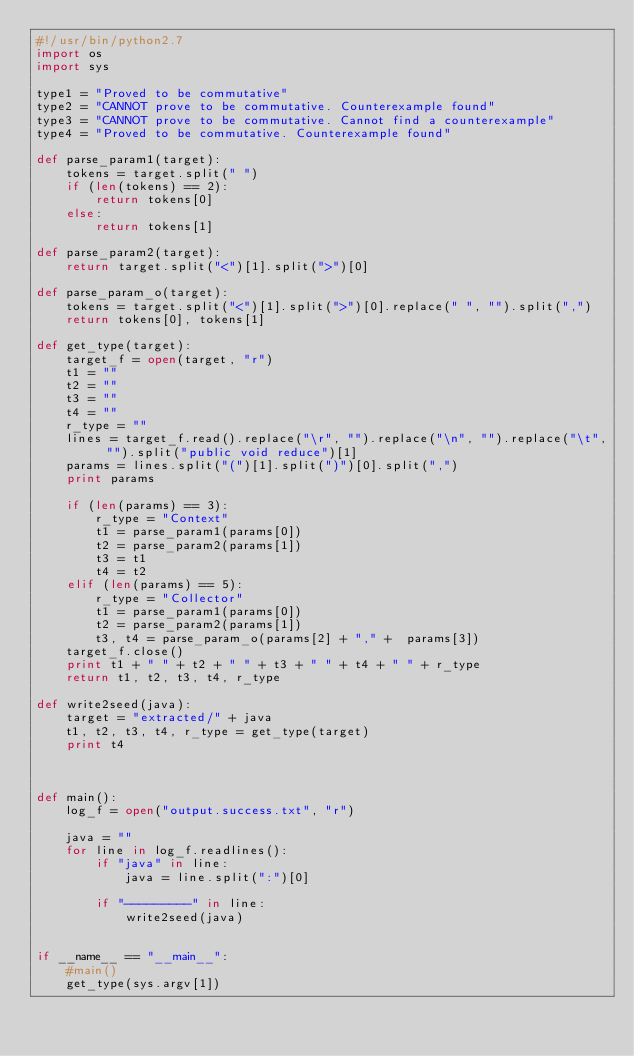Convert code to text. <code><loc_0><loc_0><loc_500><loc_500><_Python_>#!/usr/bin/python2.7
import os
import sys

type1 = "Proved to be commutative"
type2 = "CANNOT prove to be commutative. Counterexample found"
type3 = "CANNOT prove to be commutative. Cannot find a counterexample"
type4 = "Proved to be commutative. Counterexample found"

def parse_param1(target):
    tokens = target.split(" ")
    if (len(tokens) == 2):
        return tokens[0]
    else:
        return tokens[1]

def parse_param2(target):
    return target.split("<")[1].split(">")[0]

def parse_param_o(target):
    tokens = target.split("<")[1].split(">")[0].replace(" ", "").split(",")
    return tokens[0], tokens[1]

def get_type(target):
    target_f = open(target, "r")
    t1 = ""
    t2 = ""
    t3 = ""
    t4 = ""
    r_type = ""
    lines = target_f.read().replace("\r", "").replace("\n", "").replace("\t", "").split("public void reduce")[1]
    params = lines.split("(")[1].split(")")[0].split(",")
    print params

    if (len(params) == 3):
        r_type = "Context"
        t1 = parse_param1(params[0])
        t2 = parse_param2(params[1])
        t3 = t1
        t4 = t2
    elif (len(params) == 5):
        r_type = "Collector"
        t1 = parse_param1(params[0])
        t2 = parse_param2(params[1])
        t3, t4 = parse_param_o(params[2] + "," +  params[3])
    target_f.close()
    print t1 + " " + t2 + " " + t3 + " " + t4 + " " + r_type
    return t1, t2, t3, t4, r_type

def write2seed(java):
    target = "extracted/" + java
    t1, t2, t3, t4, r_type = get_type(target)
    print t4



def main():
    log_f = open("output.success.txt", "r")

    java = ""
    for line in log_f.readlines():
        if "java" in line:
            java = line.split(":")[0]

        if "---------" in line:
            write2seed(java)


if __name__ == "__main__":
    #main()
    get_type(sys.argv[1])
</code> 